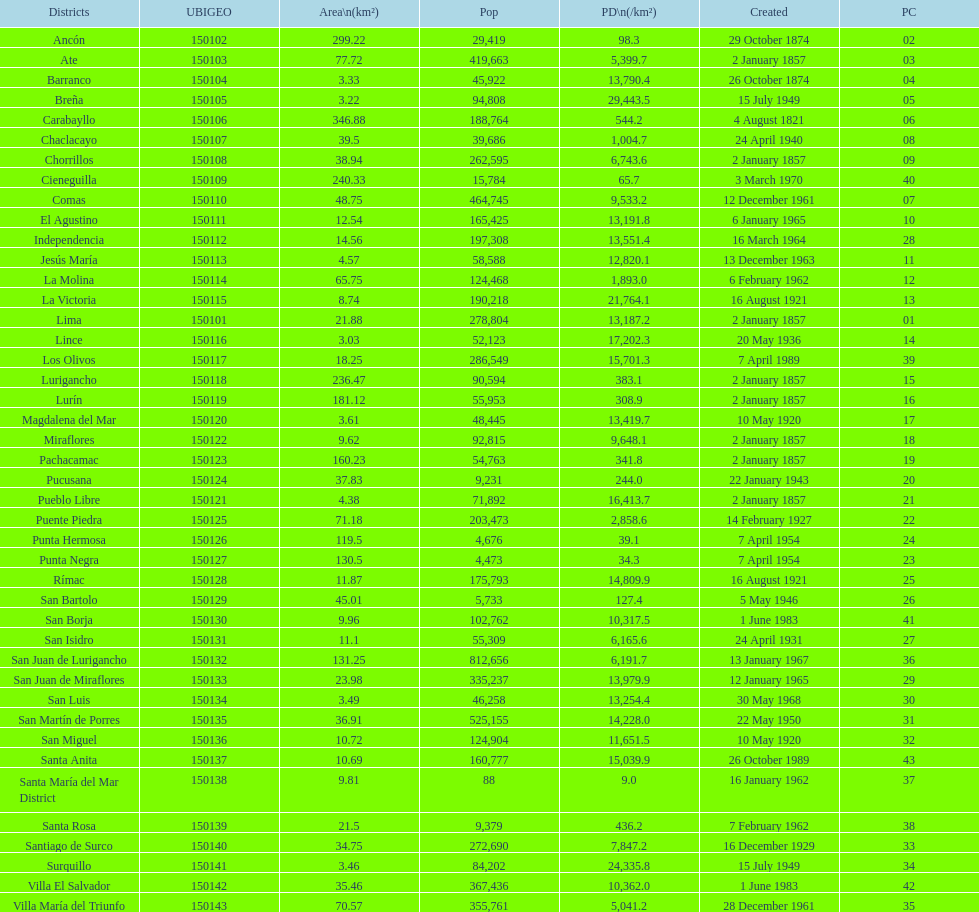Which district has the highest population? San Juan de Lurigancho. 